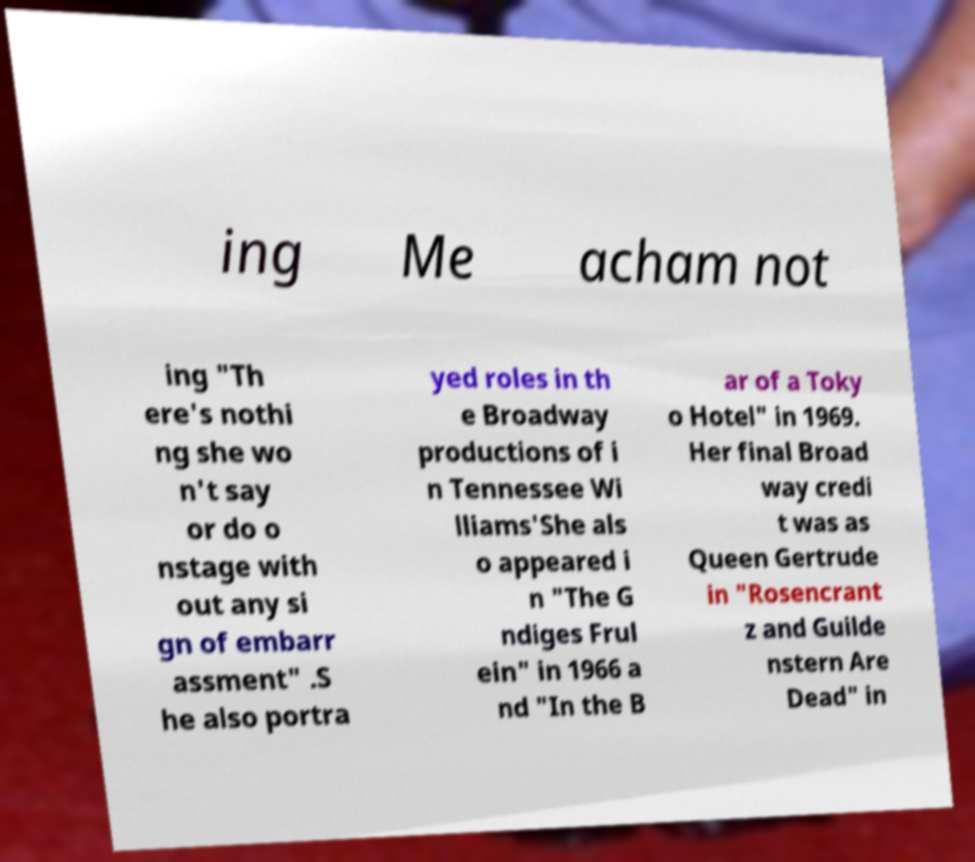There's text embedded in this image that I need extracted. Can you transcribe it verbatim? ing Me acham not ing "Th ere's nothi ng she wo n't say or do o nstage with out any si gn of embarr assment" .S he also portra yed roles in th e Broadway productions of i n Tennessee Wi lliams'She als o appeared i n "The G ndiges Frul ein" in 1966 a nd "In the B ar of a Toky o Hotel" in 1969. Her final Broad way credi t was as Queen Gertrude in "Rosencrant z and Guilde nstern Are Dead" in 